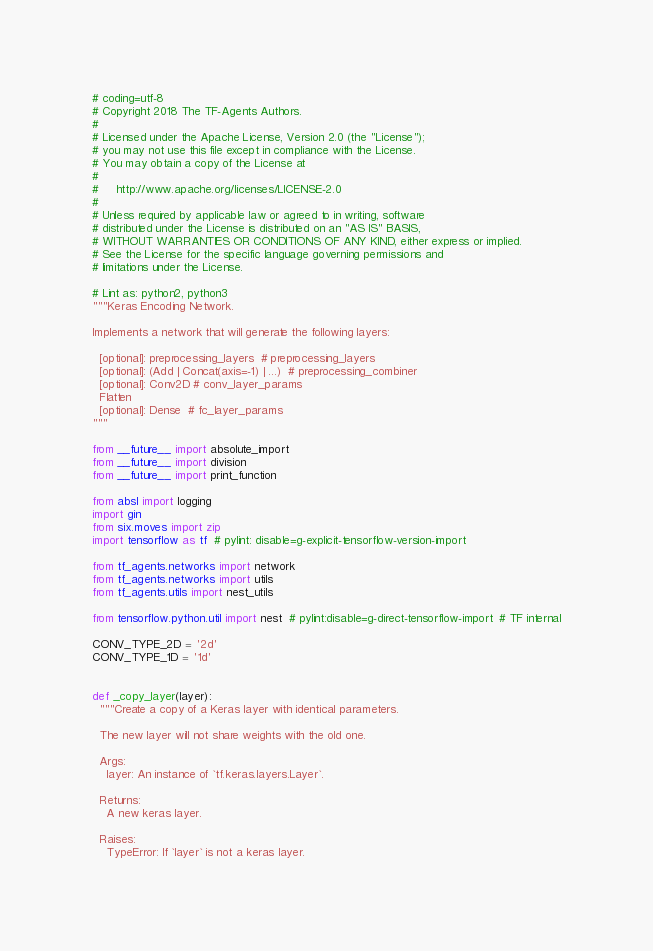Convert code to text. <code><loc_0><loc_0><loc_500><loc_500><_Python_># coding=utf-8
# Copyright 2018 The TF-Agents Authors.
#
# Licensed under the Apache License, Version 2.0 (the "License");
# you may not use this file except in compliance with the License.
# You may obtain a copy of the License at
#
#     http://www.apache.org/licenses/LICENSE-2.0
#
# Unless required by applicable law or agreed to in writing, software
# distributed under the License is distributed on an "AS IS" BASIS,
# WITHOUT WARRANTIES OR CONDITIONS OF ANY KIND, either express or implied.
# See the License for the specific language governing permissions and
# limitations under the License.

# Lint as: python2, python3
"""Keras Encoding Network.

Implements a network that will generate the following layers:

  [optional]: preprocessing_layers  # preprocessing_layers
  [optional]: (Add | Concat(axis=-1) | ...)  # preprocessing_combiner
  [optional]: Conv2D # conv_layer_params
  Flatten
  [optional]: Dense  # fc_layer_params
"""

from __future__ import absolute_import
from __future__ import division
from __future__ import print_function

from absl import logging
import gin
from six.moves import zip
import tensorflow as tf  # pylint: disable=g-explicit-tensorflow-version-import

from tf_agents.networks import network
from tf_agents.networks import utils
from tf_agents.utils import nest_utils

from tensorflow.python.util import nest  # pylint:disable=g-direct-tensorflow-import  # TF internal

CONV_TYPE_2D = '2d'
CONV_TYPE_1D = '1d'


def _copy_layer(layer):
  """Create a copy of a Keras layer with identical parameters.

  The new layer will not share weights with the old one.

  Args:
    layer: An instance of `tf.keras.layers.Layer`.

  Returns:
    A new keras layer.

  Raises:
    TypeError: If `layer` is not a keras layer.</code> 